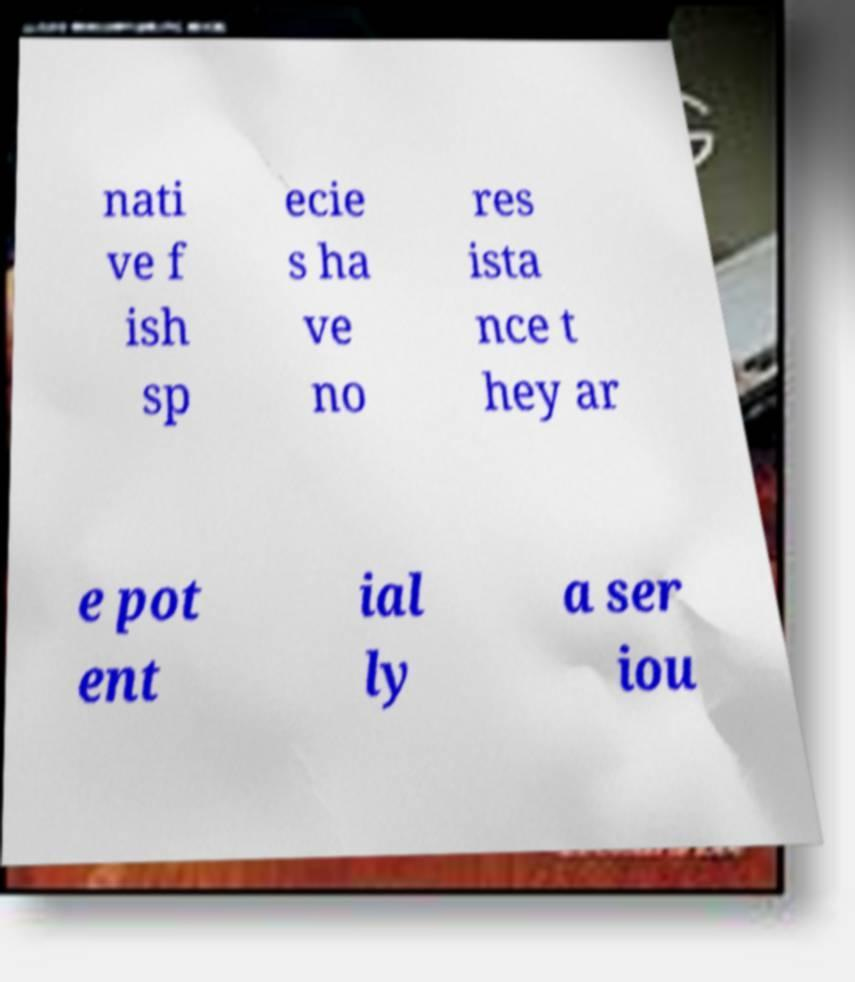Please identify and transcribe the text found in this image. nati ve f ish sp ecie s ha ve no res ista nce t hey ar e pot ent ial ly a ser iou 